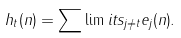Convert formula to latex. <formula><loc_0><loc_0><loc_500><loc_500>h _ { t } ( n ) = \sum \lim i t s _ { j \neq t } { e _ { j } ( n ) } .</formula> 